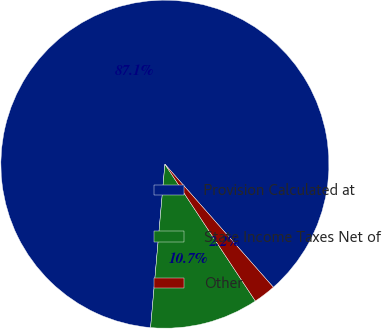Convert chart to OTSL. <chart><loc_0><loc_0><loc_500><loc_500><pie_chart><fcel>Provision Calculated at<fcel>State Income Taxes Net of<fcel>Other<nl><fcel>87.12%<fcel>10.69%<fcel>2.2%<nl></chart> 